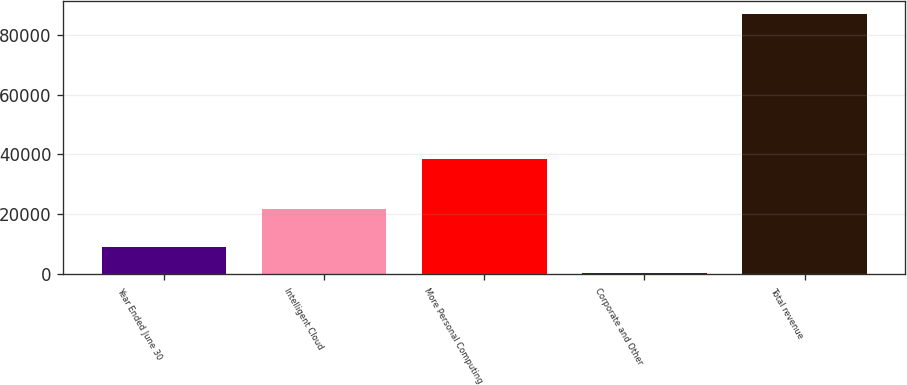Convert chart. <chart><loc_0><loc_0><loc_500><loc_500><bar_chart><fcel>Year Ended June 30<fcel>Intelligent Cloud<fcel>More Personal Computing<fcel>Corporate and Other<fcel>Total revenue<nl><fcel>8987.5<fcel>21735<fcel>38460<fcel>338<fcel>86833<nl></chart> 